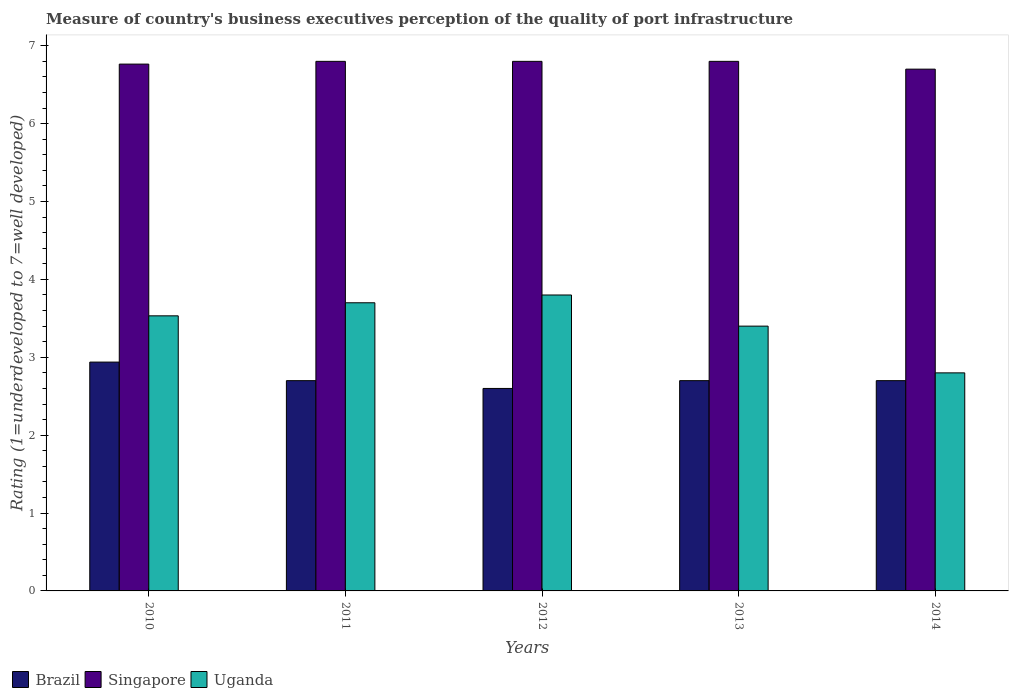How many different coloured bars are there?
Make the answer very short. 3. Are the number of bars per tick equal to the number of legend labels?
Provide a short and direct response. Yes. How many bars are there on the 3rd tick from the right?
Give a very brief answer. 3. In how many cases, is the number of bars for a given year not equal to the number of legend labels?
Your response must be concise. 0. Across all years, what is the minimum ratings of the quality of port infrastructure in Uganda?
Your answer should be very brief. 2.8. In which year was the ratings of the quality of port infrastructure in Brazil maximum?
Your answer should be very brief. 2010. What is the total ratings of the quality of port infrastructure in Brazil in the graph?
Provide a succinct answer. 13.64. What is the difference between the ratings of the quality of port infrastructure in Brazil in 2010 and that in 2013?
Your response must be concise. 0.24. What is the average ratings of the quality of port infrastructure in Singapore per year?
Your response must be concise. 6.77. In the year 2013, what is the difference between the ratings of the quality of port infrastructure in Uganda and ratings of the quality of port infrastructure in Brazil?
Ensure brevity in your answer.  0.7. What is the ratio of the ratings of the quality of port infrastructure in Singapore in 2011 to that in 2014?
Offer a very short reply. 1.01. Is the ratings of the quality of port infrastructure in Uganda in 2010 less than that in 2014?
Keep it short and to the point. No. Is the difference between the ratings of the quality of port infrastructure in Uganda in 2011 and 2014 greater than the difference between the ratings of the quality of port infrastructure in Brazil in 2011 and 2014?
Your response must be concise. Yes. What is the difference between the highest and the second highest ratings of the quality of port infrastructure in Uganda?
Give a very brief answer. 0.1. What is the difference between the highest and the lowest ratings of the quality of port infrastructure in Singapore?
Offer a terse response. 0.1. What does the 3rd bar from the left in 2012 represents?
Ensure brevity in your answer.  Uganda. What does the 3rd bar from the right in 2014 represents?
Give a very brief answer. Brazil. Are all the bars in the graph horizontal?
Provide a succinct answer. No. How many years are there in the graph?
Offer a terse response. 5. What is the difference between two consecutive major ticks on the Y-axis?
Your response must be concise. 1. Does the graph contain any zero values?
Your response must be concise. No. Does the graph contain grids?
Keep it short and to the point. No. Where does the legend appear in the graph?
Provide a short and direct response. Bottom left. How many legend labels are there?
Ensure brevity in your answer.  3. How are the legend labels stacked?
Ensure brevity in your answer.  Horizontal. What is the title of the graph?
Your answer should be very brief. Measure of country's business executives perception of the quality of port infrastructure. What is the label or title of the Y-axis?
Your answer should be compact. Rating (1=underdeveloped to 7=well developed). What is the Rating (1=underdeveloped to 7=well developed) in Brazil in 2010?
Give a very brief answer. 2.94. What is the Rating (1=underdeveloped to 7=well developed) of Singapore in 2010?
Ensure brevity in your answer.  6.76. What is the Rating (1=underdeveloped to 7=well developed) in Uganda in 2010?
Ensure brevity in your answer.  3.53. What is the Rating (1=underdeveloped to 7=well developed) in Singapore in 2011?
Your response must be concise. 6.8. What is the Rating (1=underdeveloped to 7=well developed) of Singapore in 2012?
Your answer should be very brief. 6.8. What is the Rating (1=underdeveloped to 7=well developed) in Uganda in 2012?
Your answer should be very brief. 3.8. What is the Rating (1=underdeveloped to 7=well developed) in Singapore in 2013?
Keep it short and to the point. 6.8. What is the Rating (1=underdeveloped to 7=well developed) in Singapore in 2014?
Provide a succinct answer. 6.7. Across all years, what is the maximum Rating (1=underdeveloped to 7=well developed) in Brazil?
Your answer should be compact. 2.94. Across all years, what is the maximum Rating (1=underdeveloped to 7=well developed) of Uganda?
Give a very brief answer. 3.8. Across all years, what is the minimum Rating (1=underdeveloped to 7=well developed) of Brazil?
Make the answer very short. 2.6. Across all years, what is the minimum Rating (1=underdeveloped to 7=well developed) in Singapore?
Your answer should be very brief. 6.7. What is the total Rating (1=underdeveloped to 7=well developed) of Brazil in the graph?
Provide a succinct answer. 13.64. What is the total Rating (1=underdeveloped to 7=well developed) of Singapore in the graph?
Give a very brief answer. 33.86. What is the total Rating (1=underdeveloped to 7=well developed) in Uganda in the graph?
Keep it short and to the point. 17.23. What is the difference between the Rating (1=underdeveloped to 7=well developed) of Brazil in 2010 and that in 2011?
Ensure brevity in your answer.  0.24. What is the difference between the Rating (1=underdeveloped to 7=well developed) in Singapore in 2010 and that in 2011?
Offer a terse response. -0.04. What is the difference between the Rating (1=underdeveloped to 7=well developed) in Uganda in 2010 and that in 2011?
Offer a very short reply. -0.17. What is the difference between the Rating (1=underdeveloped to 7=well developed) of Brazil in 2010 and that in 2012?
Offer a very short reply. 0.34. What is the difference between the Rating (1=underdeveloped to 7=well developed) of Singapore in 2010 and that in 2012?
Ensure brevity in your answer.  -0.04. What is the difference between the Rating (1=underdeveloped to 7=well developed) of Uganda in 2010 and that in 2012?
Make the answer very short. -0.27. What is the difference between the Rating (1=underdeveloped to 7=well developed) in Brazil in 2010 and that in 2013?
Offer a terse response. 0.24. What is the difference between the Rating (1=underdeveloped to 7=well developed) of Singapore in 2010 and that in 2013?
Your answer should be compact. -0.04. What is the difference between the Rating (1=underdeveloped to 7=well developed) in Uganda in 2010 and that in 2013?
Keep it short and to the point. 0.13. What is the difference between the Rating (1=underdeveloped to 7=well developed) of Brazil in 2010 and that in 2014?
Keep it short and to the point. 0.24. What is the difference between the Rating (1=underdeveloped to 7=well developed) of Singapore in 2010 and that in 2014?
Offer a terse response. 0.06. What is the difference between the Rating (1=underdeveloped to 7=well developed) of Uganda in 2010 and that in 2014?
Provide a succinct answer. 0.73. What is the difference between the Rating (1=underdeveloped to 7=well developed) of Uganda in 2011 and that in 2012?
Your answer should be compact. -0.1. What is the difference between the Rating (1=underdeveloped to 7=well developed) in Brazil in 2011 and that in 2013?
Your answer should be very brief. 0. What is the difference between the Rating (1=underdeveloped to 7=well developed) in Brazil in 2011 and that in 2014?
Give a very brief answer. 0. What is the difference between the Rating (1=underdeveloped to 7=well developed) of Singapore in 2011 and that in 2014?
Make the answer very short. 0.1. What is the difference between the Rating (1=underdeveloped to 7=well developed) in Singapore in 2012 and that in 2013?
Provide a succinct answer. 0. What is the difference between the Rating (1=underdeveloped to 7=well developed) in Singapore in 2012 and that in 2014?
Keep it short and to the point. 0.1. What is the difference between the Rating (1=underdeveloped to 7=well developed) in Uganda in 2012 and that in 2014?
Give a very brief answer. 1. What is the difference between the Rating (1=underdeveloped to 7=well developed) in Brazil in 2010 and the Rating (1=underdeveloped to 7=well developed) in Singapore in 2011?
Your response must be concise. -3.86. What is the difference between the Rating (1=underdeveloped to 7=well developed) in Brazil in 2010 and the Rating (1=underdeveloped to 7=well developed) in Uganda in 2011?
Offer a very short reply. -0.76. What is the difference between the Rating (1=underdeveloped to 7=well developed) of Singapore in 2010 and the Rating (1=underdeveloped to 7=well developed) of Uganda in 2011?
Make the answer very short. 3.06. What is the difference between the Rating (1=underdeveloped to 7=well developed) of Brazil in 2010 and the Rating (1=underdeveloped to 7=well developed) of Singapore in 2012?
Provide a short and direct response. -3.86. What is the difference between the Rating (1=underdeveloped to 7=well developed) in Brazil in 2010 and the Rating (1=underdeveloped to 7=well developed) in Uganda in 2012?
Provide a succinct answer. -0.86. What is the difference between the Rating (1=underdeveloped to 7=well developed) in Singapore in 2010 and the Rating (1=underdeveloped to 7=well developed) in Uganda in 2012?
Your answer should be very brief. 2.96. What is the difference between the Rating (1=underdeveloped to 7=well developed) in Brazil in 2010 and the Rating (1=underdeveloped to 7=well developed) in Singapore in 2013?
Your answer should be compact. -3.86. What is the difference between the Rating (1=underdeveloped to 7=well developed) in Brazil in 2010 and the Rating (1=underdeveloped to 7=well developed) in Uganda in 2013?
Provide a succinct answer. -0.46. What is the difference between the Rating (1=underdeveloped to 7=well developed) of Singapore in 2010 and the Rating (1=underdeveloped to 7=well developed) of Uganda in 2013?
Keep it short and to the point. 3.36. What is the difference between the Rating (1=underdeveloped to 7=well developed) of Brazil in 2010 and the Rating (1=underdeveloped to 7=well developed) of Singapore in 2014?
Offer a terse response. -3.76. What is the difference between the Rating (1=underdeveloped to 7=well developed) in Brazil in 2010 and the Rating (1=underdeveloped to 7=well developed) in Uganda in 2014?
Offer a terse response. 0.14. What is the difference between the Rating (1=underdeveloped to 7=well developed) of Singapore in 2010 and the Rating (1=underdeveloped to 7=well developed) of Uganda in 2014?
Make the answer very short. 3.96. What is the difference between the Rating (1=underdeveloped to 7=well developed) in Singapore in 2011 and the Rating (1=underdeveloped to 7=well developed) in Uganda in 2012?
Your answer should be compact. 3. What is the difference between the Rating (1=underdeveloped to 7=well developed) of Brazil in 2011 and the Rating (1=underdeveloped to 7=well developed) of Singapore in 2013?
Provide a short and direct response. -4.1. What is the difference between the Rating (1=underdeveloped to 7=well developed) of Brazil in 2011 and the Rating (1=underdeveloped to 7=well developed) of Uganda in 2013?
Give a very brief answer. -0.7. What is the difference between the Rating (1=underdeveloped to 7=well developed) in Singapore in 2011 and the Rating (1=underdeveloped to 7=well developed) in Uganda in 2013?
Your answer should be very brief. 3.4. What is the difference between the Rating (1=underdeveloped to 7=well developed) of Brazil in 2011 and the Rating (1=underdeveloped to 7=well developed) of Singapore in 2014?
Your answer should be very brief. -4. What is the difference between the Rating (1=underdeveloped to 7=well developed) of Brazil in 2011 and the Rating (1=underdeveloped to 7=well developed) of Uganda in 2014?
Offer a very short reply. -0.1. What is the difference between the Rating (1=underdeveloped to 7=well developed) in Brazil in 2012 and the Rating (1=underdeveloped to 7=well developed) in Uganda in 2013?
Make the answer very short. -0.8. What is the difference between the Rating (1=underdeveloped to 7=well developed) in Singapore in 2012 and the Rating (1=underdeveloped to 7=well developed) in Uganda in 2013?
Make the answer very short. 3.4. What is the difference between the Rating (1=underdeveloped to 7=well developed) of Singapore in 2012 and the Rating (1=underdeveloped to 7=well developed) of Uganda in 2014?
Provide a succinct answer. 4. What is the difference between the Rating (1=underdeveloped to 7=well developed) of Brazil in 2013 and the Rating (1=underdeveloped to 7=well developed) of Singapore in 2014?
Offer a very short reply. -4. What is the difference between the Rating (1=underdeveloped to 7=well developed) of Brazil in 2013 and the Rating (1=underdeveloped to 7=well developed) of Uganda in 2014?
Offer a very short reply. -0.1. What is the average Rating (1=underdeveloped to 7=well developed) of Brazil per year?
Give a very brief answer. 2.73. What is the average Rating (1=underdeveloped to 7=well developed) of Singapore per year?
Your answer should be compact. 6.77. What is the average Rating (1=underdeveloped to 7=well developed) of Uganda per year?
Your response must be concise. 3.45. In the year 2010, what is the difference between the Rating (1=underdeveloped to 7=well developed) in Brazil and Rating (1=underdeveloped to 7=well developed) in Singapore?
Offer a very short reply. -3.83. In the year 2010, what is the difference between the Rating (1=underdeveloped to 7=well developed) in Brazil and Rating (1=underdeveloped to 7=well developed) in Uganda?
Your response must be concise. -0.59. In the year 2010, what is the difference between the Rating (1=underdeveloped to 7=well developed) in Singapore and Rating (1=underdeveloped to 7=well developed) in Uganda?
Give a very brief answer. 3.23. In the year 2011, what is the difference between the Rating (1=underdeveloped to 7=well developed) of Brazil and Rating (1=underdeveloped to 7=well developed) of Singapore?
Give a very brief answer. -4.1. In the year 2011, what is the difference between the Rating (1=underdeveloped to 7=well developed) of Brazil and Rating (1=underdeveloped to 7=well developed) of Uganda?
Your answer should be compact. -1. In the year 2011, what is the difference between the Rating (1=underdeveloped to 7=well developed) in Singapore and Rating (1=underdeveloped to 7=well developed) in Uganda?
Your answer should be very brief. 3.1. In the year 2013, what is the difference between the Rating (1=underdeveloped to 7=well developed) in Brazil and Rating (1=underdeveloped to 7=well developed) in Uganda?
Offer a very short reply. -0.7. In the year 2013, what is the difference between the Rating (1=underdeveloped to 7=well developed) in Singapore and Rating (1=underdeveloped to 7=well developed) in Uganda?
Ensure brevity in your answer.  3.4. What is the ratio of the Rating (1=underdeveloped to 7=well developed) of Brazil in 2010 to that in 2011?
Your answer should be very brief. 1.09. What is the ratio of the Rating (1=underdeveloped to 7=well developed) in Singapore in 2010 to that in 2011?
Make the answer very short. 0.99. What is the ratio of the Rating (1=underdeveloped to 7=well developed) of Uganda in 2010 to that in 2011?
Make the answer very short. 0.95. What is the ratio of the Rating (1=underdeveloped to 7=well developed) in Brazil in 2010 to that in 2012?
Keep it short and to the point. 1.13. What is the ratio of the Rating (1=underdeveloped to 7=well developed) of Uganda in 2010 to that in 2012?
Keep it short and to the point. 0.93. What is the ratio of the Rating (1=underdeveloped to 7=well developed) in Brazil in 2010 to that in 2013?
Keep it short and to the point. 1.09. What is the ratio of the Rating (1=underdeveloped to 7=well developed) in Uganda in 2010 to that in 2013?
Make the answer very short. 1.04. What is the ratio of the Rating (1=underdeveloped to 7=well developed) of Brazil in 2010 to that in 2014?
Offer a terse response. 1.09. What is the ratio of the Rating (1=underdeveloped to 7=well developed) of Singapore in 2010 to that in 2014?
Provide a short and direct response. 1.01. What is the ratio of the Rating (1=underdeveloped to 7=well developed) in Uganda in 2010 to that in 2014?
Your response must be concise. 1.26. What is the ratio of the Rating (1=underdeveloped to 7=well developed) of Brazil in 2011 to that in 2012?
Offer a terse response. 1.04. What is the ratio of the Rating (1=underdeveloped to 7=well developed) of Uganda in 2011 to that in 2012?
Your answer should be very brief. 0.97. What is the ratio of the Rating (1=underdeveloped to 7=well developed) of Singapore in 2011 to that in 2013?
Give a very brief answer. 1. What is the ratio of the Rating (1=underdeveloped to 7=well developed) in Uganda in 2011 to that in 2013?
Keep it short and to the point. 1.09. What is the ratio of the Rating (1=underdeveloped to 7=well developed) in Singapore in 2011 to that in 2014?
Offer a very short reply. 1.01. What is the ratio of the Rating (1=underdeveloped to 7=well developed) of Uganda in 2011 to that in 2014?
Provide a short and direct response. 1.32. What is the ratio of the Rating (1=underdeveloped to 7=well developed) of Brazil in 2012 to that in 2013?
Provide a succinct answer. 0.96. What is the ratio of the Rating (1=underdeveloped to 7=well developed) of Singapore in 2012 to that in 2013?
Offer a terse response. 1. What is the ratio of the Rating (1=underdeveloped to 7=well developed) in Uganda in 2012 to that in 2013?
Provide a short and direct response. 1.12. What is the ratio of the Rating (1=underdeveloped to 7=well developed) in Brazil in 2012 to that in 2014?
Offer a terse response. 0.96. What is the ratio of the Rating (1=underdeveloped to 7=well developed) in Singapore in 2012 to that in 2014?
Your answer should be compact. 1.01. What is the ratio of the Rating (1=underdeveloped to 7=well developed) in Uganda in 2012 to that in 2014?
Your response must be concise. 1.36. What is the ratio of the Rating (1=underdeveloped to 7=well developed) of Singapore in 2013 to that in 2014?
Your answer should be compact. 1.01. What is the ratio of the Rating (1=underdeveloped to 7=well developed) of Uganda in 2013 to that in 2014?
Your answer should be very brief. 1.21. What is the difference between the highest and the second highest Rating (1=underdeveloped to 7=well developed) in Brazil?
Make the answer very short. 0.24. What is the difference between the highest and the lowest Rating (1=underdeveloped to 7=well developed) of Brazil?
Offer a terse response. 0.34. What is the difference between the highest and the lowest Rating (1=underdeveloped to 7=well developed) in Singapore?
Ensure brevity in your answer.  0.1. 